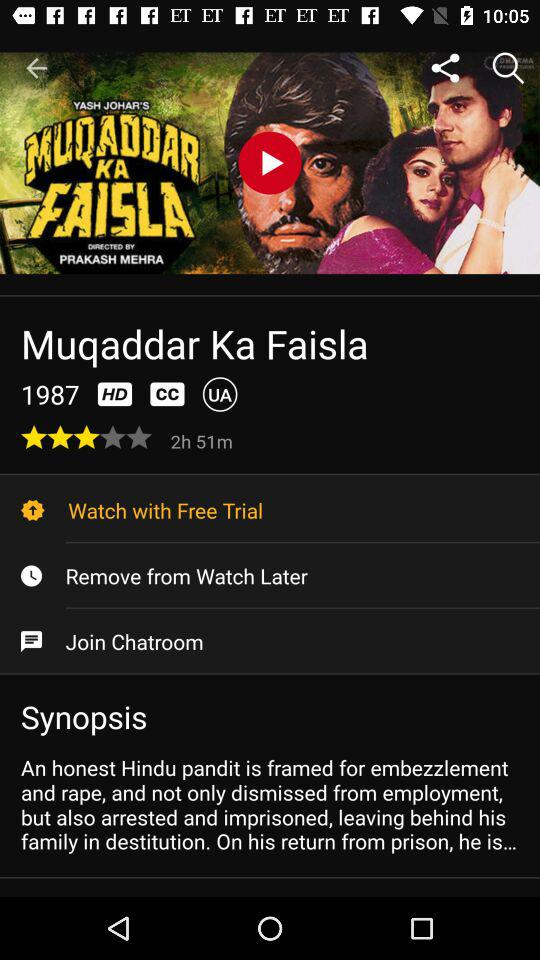Who is the director of the movie? The director of the movie is Prakash Mehra. 